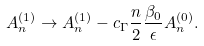Convert formula to latex. <formula><loc_0><loc_0><loc_500><loc_500>A ^ { ( 1 ) } _ { n } \to A ^ { ( 1 ) } _ { n } - c _ { \Gamma } \frac { n } { 2 } \frac { \beta _ { 0 } } { \epsilon } A ^ { ( 0 ) } _ { n } .</formula> 